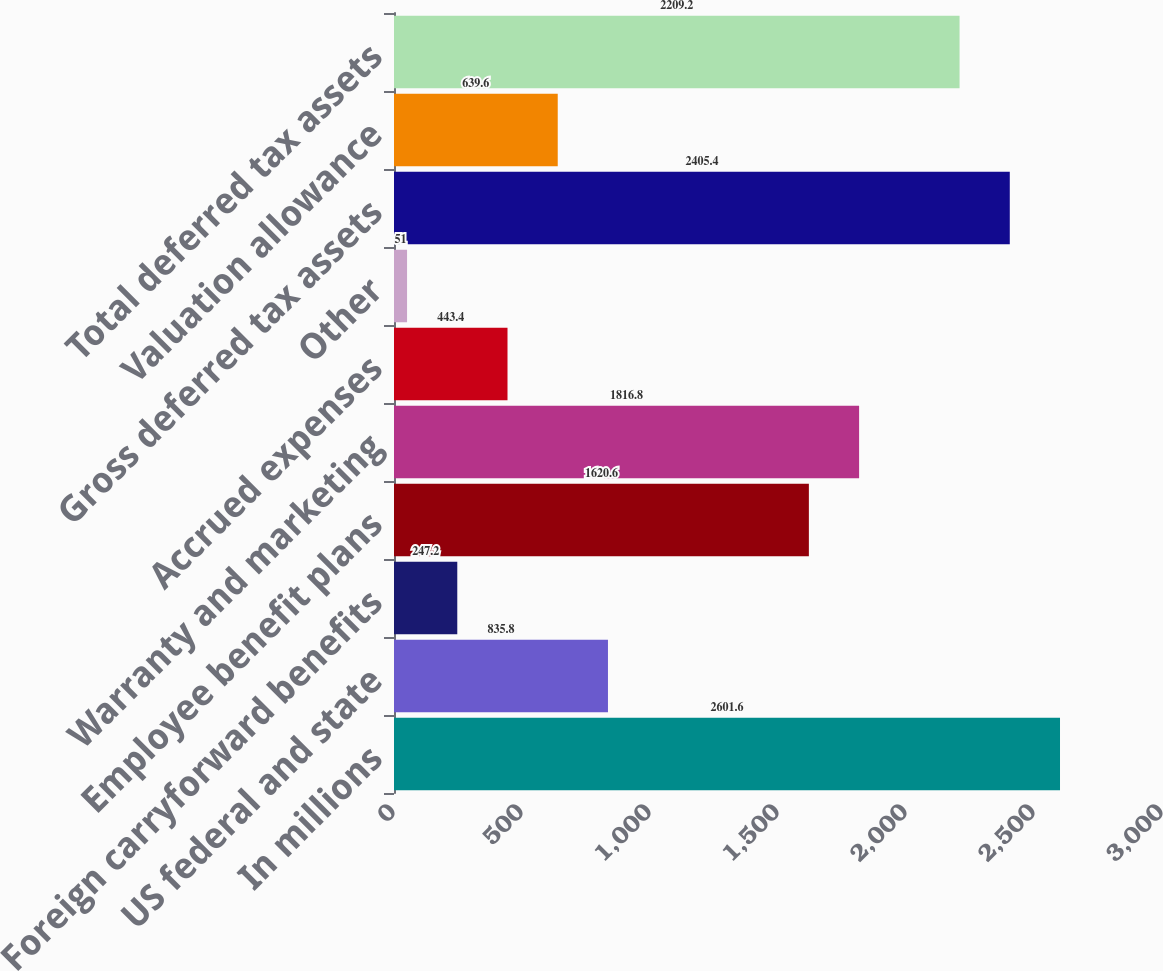<chart> <loc_0><loc_0><loc_500><loc_500><bar_chart><fcel>In millions<fcel>US federal and state<fcel>Foreign carryforward benefits<fcel>Employee benefit plans<fcel>Warranty and marketing<fcel>Accrued expenses<fcel>Other<fcel>Gross deferred tax assets<fcel>Valuation allowance<fcel>Total deferred tax assets<nl><fcel>2601.6<fcel>835.8<fcel>247.2<fcel>1620.6<fcel>1816.8<fcel>443.4<fcel>51<fcel>2405.4<fcel>639.6<fcel>2209.2<nl></chart> 